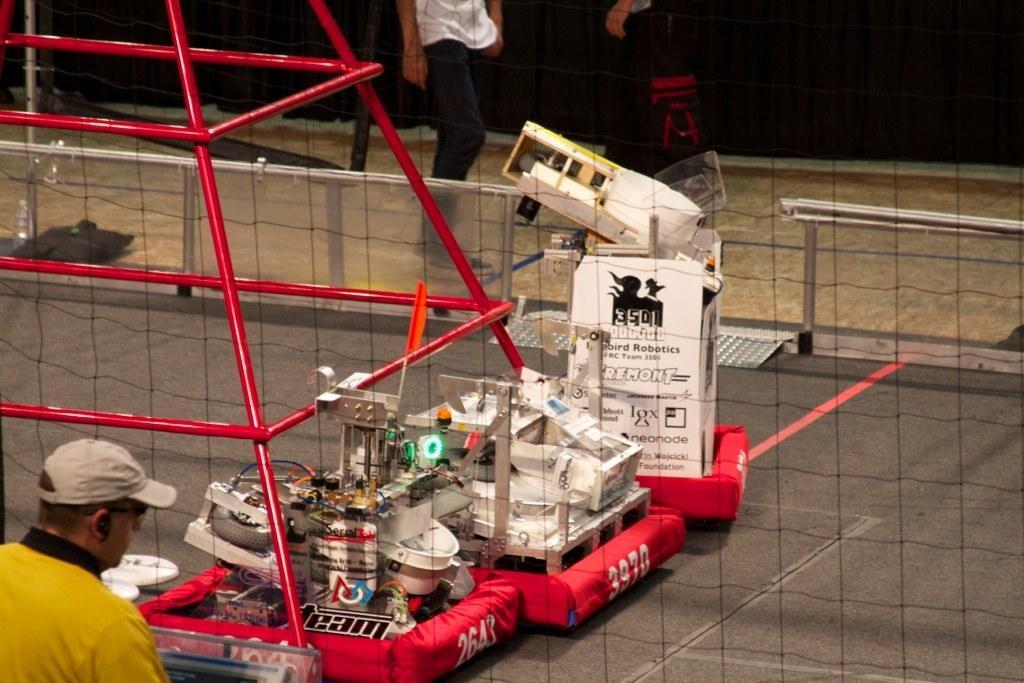How would you summarize this image in a sentence or two? In the picture I can see people, a net, machines and some other things. In the background I can see a fence. 